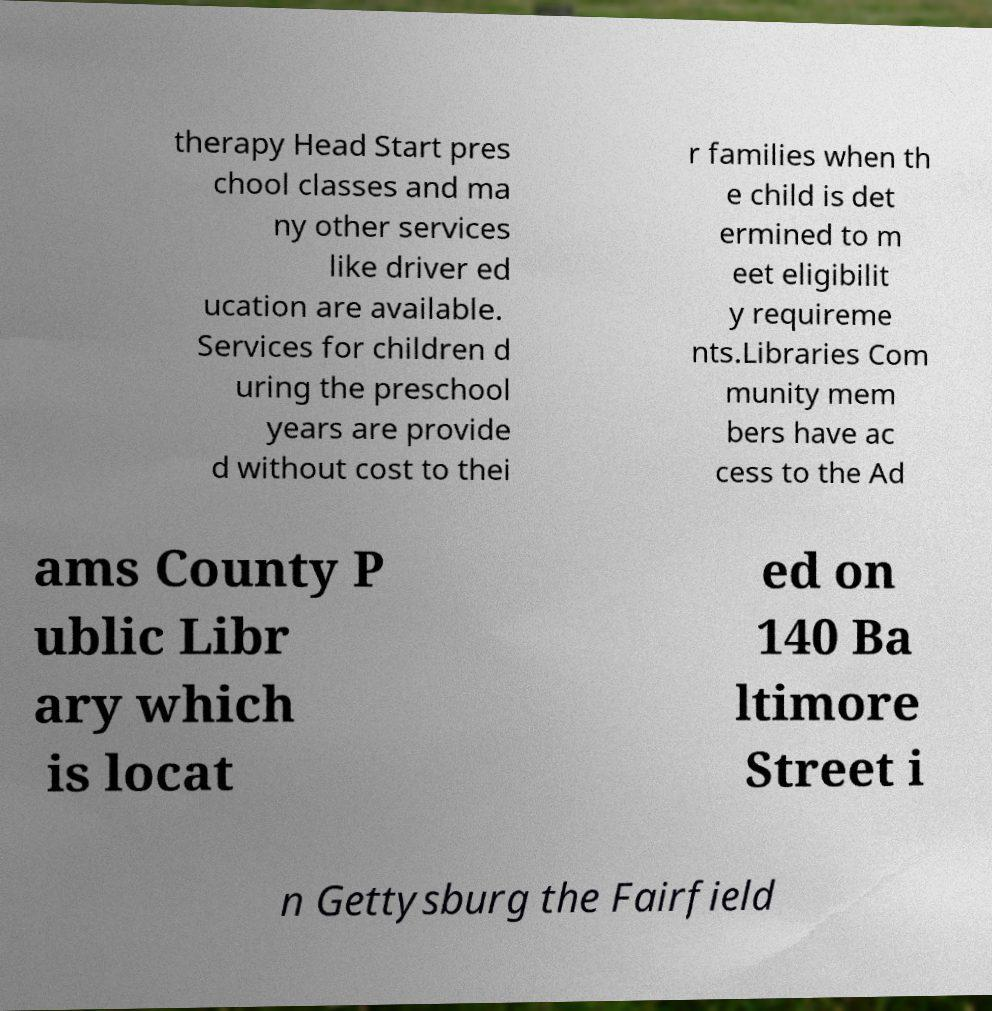For documentation purposes, I need the text within this image transcribed. Could you provide that? therapy Head Start pres chool classes and ma ny other services like driver ed ucation are available. Services for children d uring the preschool years are provide d without cost to thei r families when th e child is det ermined to m eet eligibilit y requireme nts.Libraries Com munity mem bers have ac cess to the Ad ams County P ublic Libr ary which is locat ed on 140 Ba ltimore Street i n Gettysburg the Fairfield 